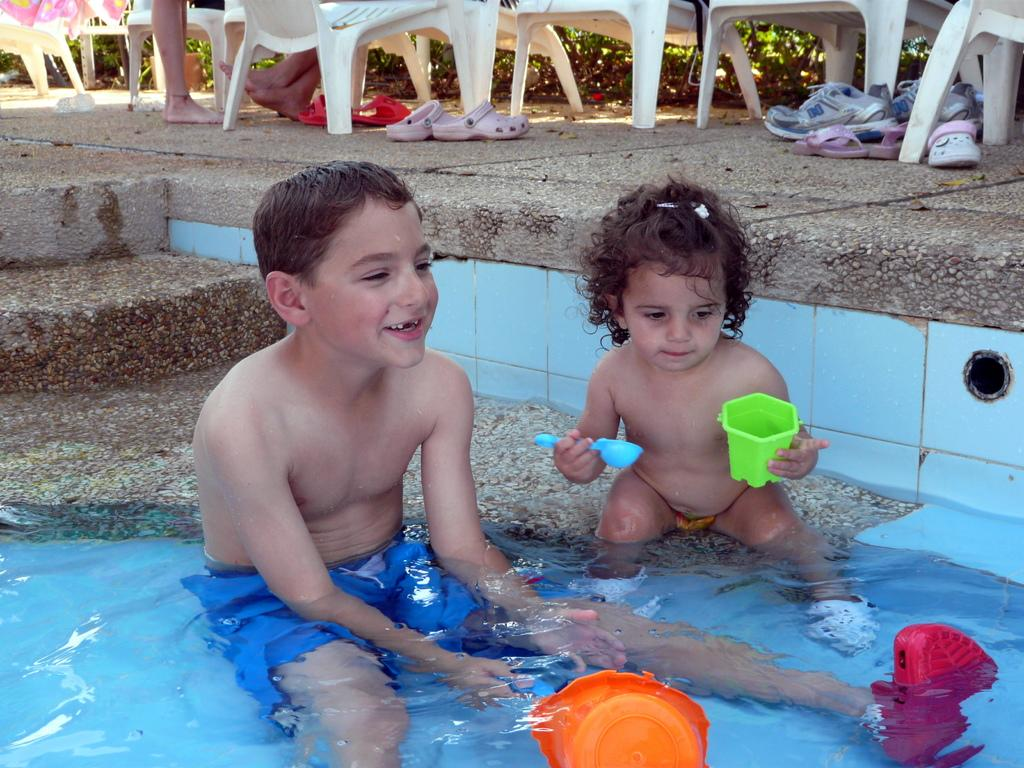How many kids are in the image? There are two kids in the image. Where are the kids located in the image? The kids are sitting in a swimming pool. What are the kids holding in the image? The kids are holding cups and spoons. What can be seen at the top of the image? Chairs, footwear, and grass are visible at the top of the image. What type of animal is playing with the toys in the image? There are no toys or animals present in the image. Can you describe the taste of the ice cream the kids are eating in the image? There is no ice cream present in the image; the kids are holding cups and spoons. 